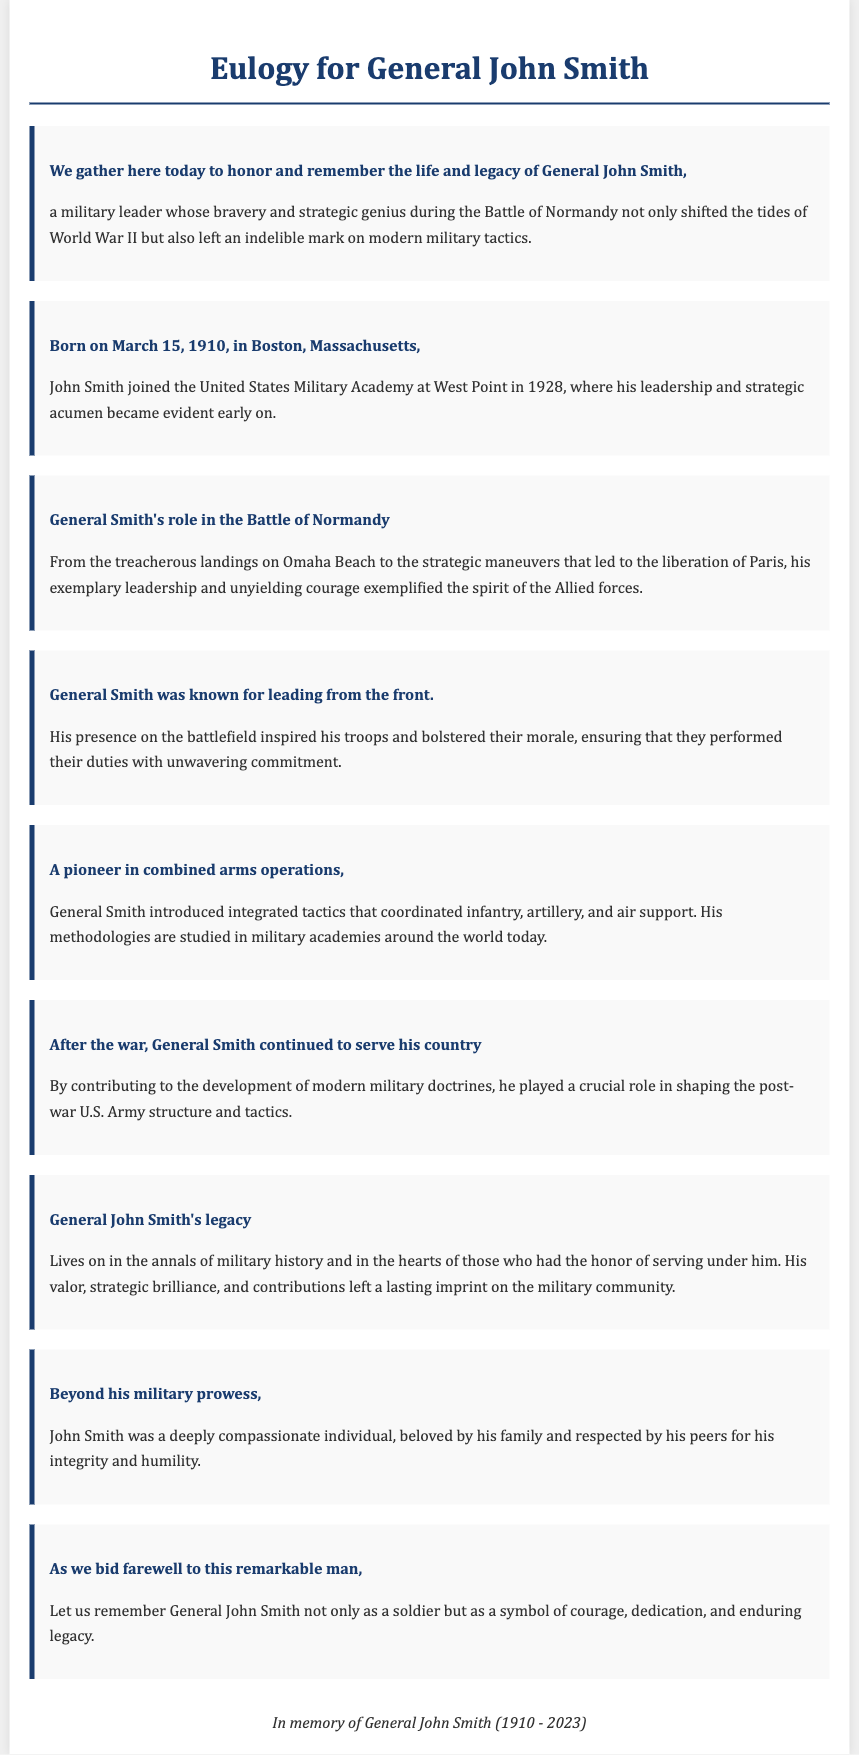What date was General John Smith born? General John Smith was born on March 15, 1910, as stated in the document.
Answer: March 15, 1910 What battle is General John Smith most renowned for? The document states that General Smith's bravery and strategic genius were particularly noted during the Battle of Normandy.
Answer: Battle of Normandy What role did General Smith play in the Battle of Normandy? He had a key leadership role, overseeing treacherous landings and strategic maneuvers, as detailed in the document.
Answer: Leadership What tactics did General Smith pioneer? The document mentions that he introduced integrated tactics that coordinated infantry, artillery, and air support.
Answer: Combined arms operations How long did General John Smith live? The document lists his lifespan as 1910 to 2023, indicating he lived for 113 years.
Answer: 113 years What was a key characteristic of General Smith's leadership style? The document notes that he was known for leading from the front, which inspired his troops.
Answer: Leading from the front What was General Smith's contribution to military structure after the war? He played a crucial role in shaping post-war U.S. Army structure and tactics, as outlined in the document.
Answer: Shaping post-war U.S. Army What personal trait is highlighted about General Smith? The document describes him as a deeply compassionate individual, valued for his integrity and humility.
Answer: Compassionate 